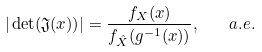<formula> <loc_0><loc_0><loc_500><loc_500>| \det ( \mathfrak { J } ( x ) ) | = \frac { f _ { X } ( x ) } { f _ { \hat { X } } ( g ^ { - 1 } ( x ) ) } , \quad a . e .</formula> 